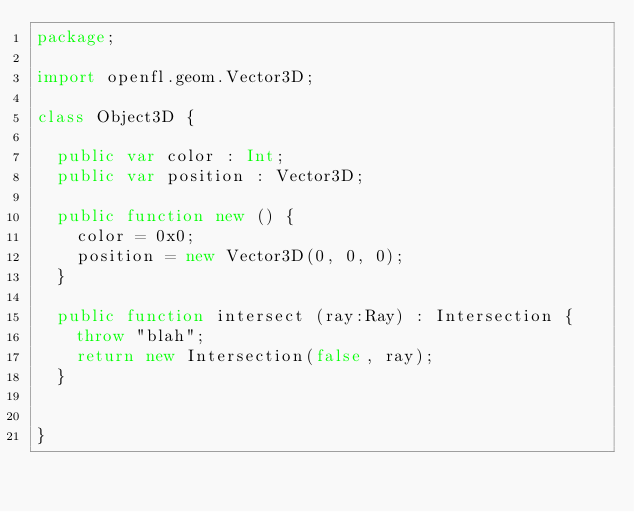<code> <loc_0><loc_0><loc_500><loc_500><_Haxe_>package;

import openfl.geom.Vector3D;

class Object3D {

  public var color : Int;
  public var position : Vector3D;

  public function new () {
    color = 0x0;
    position = new Vector3D(0, 0, 0);
  }

  public function intersect (ray:Ray) : Intersection {
    throw "blah";
    return new Intersection(false, ray);
  }


}
</code> 